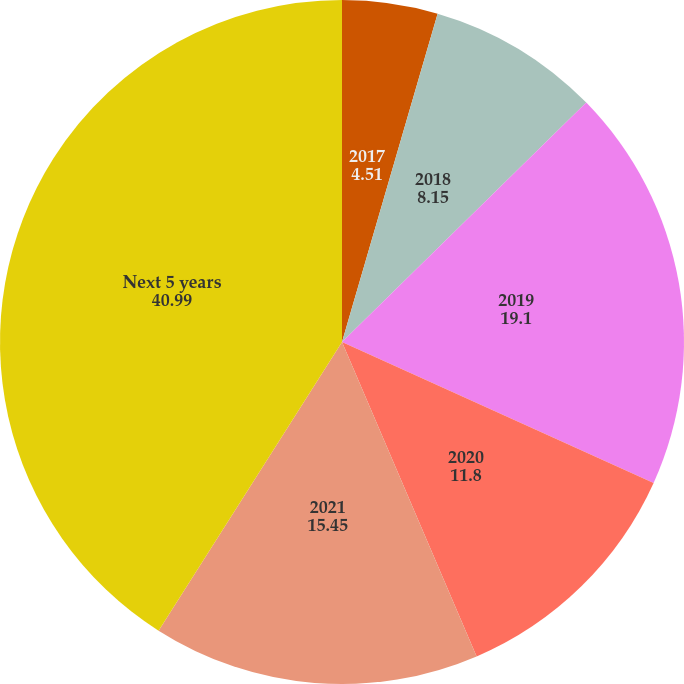Convert chart to OTSL. <chart><loc_0><loc_0><loc_500><loc_500><pie_chart><fcel>2017<fcel>2018<fcel>2019<fcel>2020<fcel>2021<fcel>Next 5 years<nl><fcel>4.51%<fcel>8.15%<fcel>19.1%<fcel>11.8%<fcel>15.45%<fcel>40.99%<nl></chart> 